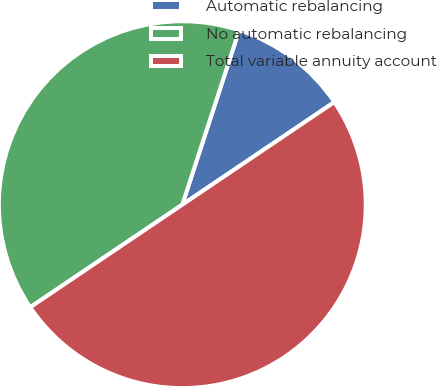Convert chart to OTSL. <chart><loc_0><loc_0><loc_500><loc_500><pie_chart><fcel>Automatic rebalancing<fcel>No automatic rebalancing<fcel>Total variable annuity account<nl><fcel>10.54%<fcel>39.46%<fcel>50.0%<nl></chart> 